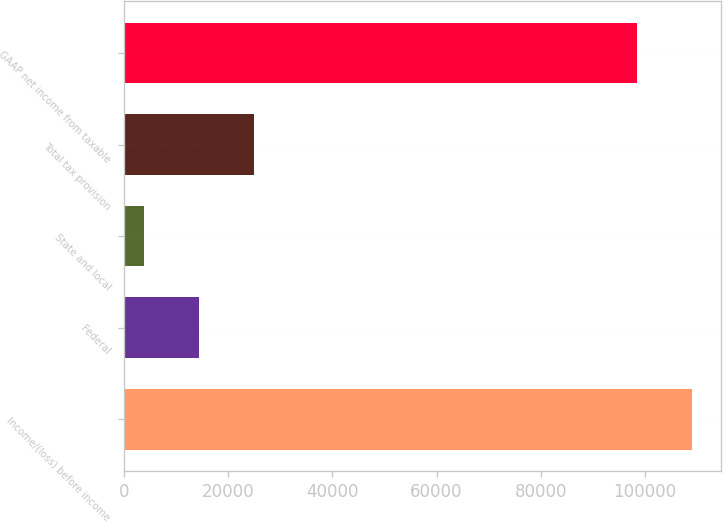Convert chart. <chart><loc_0><loc_0><loc_500><loc_500><bar_chart><fcel>Income/(loss) before income<fcel>Federal<fcel>State and local<fcel>Total tax provision<fcel>GAAP net income from taxable<nl><fcel>109057<fcel>14460.7<fcel>3950<fcel>24971.4<fcel>98542<nl></chart> 